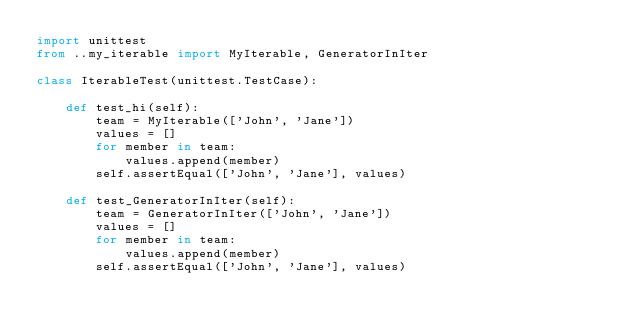Convert code to text. <code><loc_0><loc_0><loc_500><loc_500><_Python_>import unittest
from ..my_iterable import MyIterable, GeneratorInIter

class IterableTest(unittest.TestCase):

    def test_hi(self):
        team = MyIterable(['John', 'Jane'])
        values = []
        for member in team:
            values.append(member)
        self.assertEqual(['John', 'Jane'], values)

    def test_GeneratorInIter(self):
        team = GeneratorInIter(['John', 'Jane'])
        values = []
        for member in team:
            values.append(member)
        self.assertEqual(['John', 'Jane'], values)

 </code> 